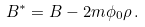<formula> <loc_0><loc_0><loc_500><loc_500>B ^ { * } = B - 2 m \phi _ { 0 } \rho \, .</formula> 